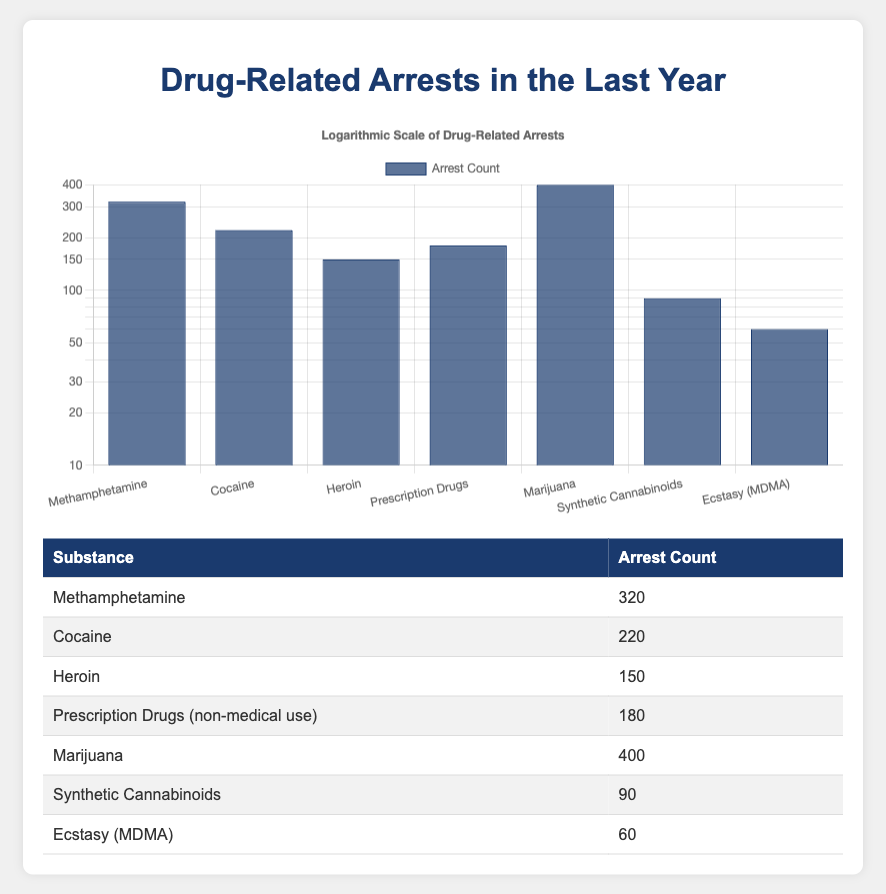What substance had the highest number of arrests? The table lists the arrest counts for each substance. By comparing the values, Marijuana has the highest count at 400.
Answer: Marijuana How many arrests were related to Cocaine? The table shows that the arrest count for Cocaine is directly listed as 220.
Answer: 220 What is the total number of arrests for Methamphetamine and Prescription Drugs combined? Adding the arrest counts for both substances, Methamphetamine has 320 arrests and Prescription Drugs has 180. The total is 320 + 180 = 500.
Answer: 500 Is the arrest count for Synthetic Cannabinoids greater than that for Ecstasy (MDMA)? The arrest count for Synthetic Cannabinoids is 90, while for Ecstasy (MDMA) it is 60. Since 90 is greater than 60, the statement is true.
Answer: Yes What is the average number of arrests for all substances listed? To calculate the average, first sum all the arrest counts: 320 + 220 + 150 + 180 + 400 + 90 + 60 = 1420. Since there are 7 substances, the average is 1420 / 7 = 202.86.
Answer: 202.86 How many more arrests were made for Heroin than for Ecstasy (MDMA)? The arrest count for Heroin is 150, and for Ecstasy (MDMA) it is 60. The difference is calculated as 150 - 60 = 90.
Answer: 90 Which substance has the second highest arrest count? By examining the table, the arrest counts from highest to lowest are: Marijuana (400), Methamphetamine (320), Cocaine (220), etc. Hence, Methamphetamine is the second highest with 320.
Answer: Methamphetamine Are there more arrests for Prescription Drugs than for Heroin? Prescription Drugs have an arrest count of 180, while Heroin has a count of 150. Since 180 is greater than 150, the statement is true.
Answer: Yes 